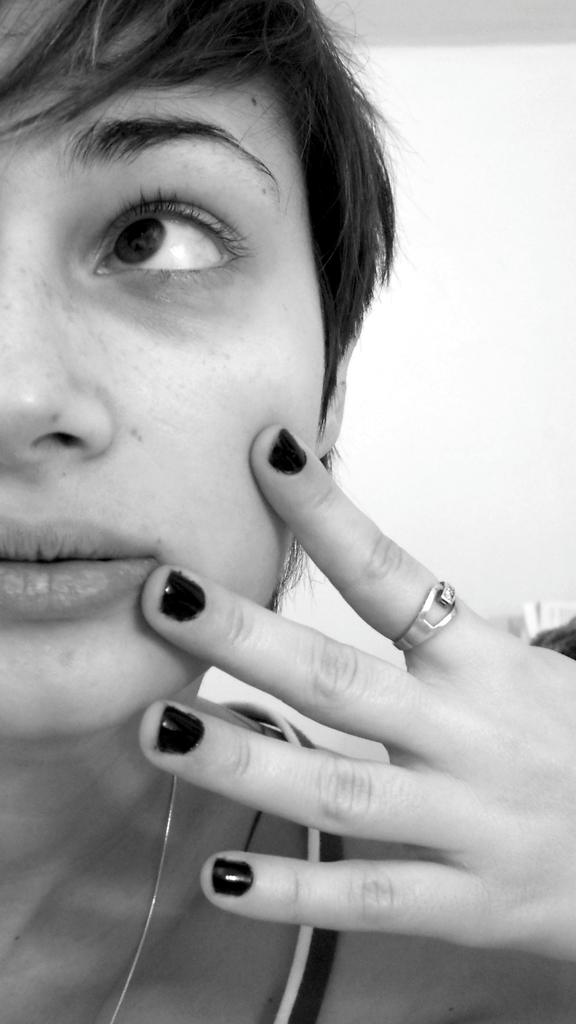Who is present in the image? There is a woman in the picture. What can be seen in the background of the image? There is a wall in the background of the picture. Are there any objects on a table in the image? It is mentioned that there might be books on a table in the picture. What type of bells can be heard ringing in the image? There are no bells present in the image, and therefore no sound can be heard. 